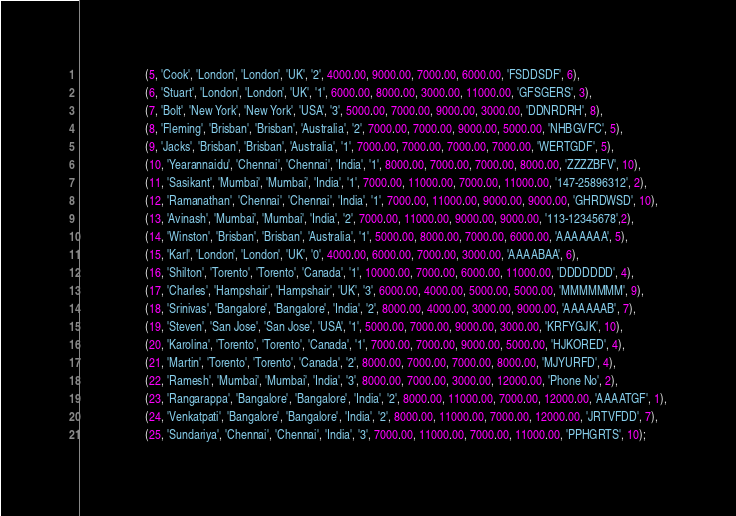<code> <loc_0><loc_0><loc_500><loc_500><_SQL_>                      (5, 'Cook', 'London', 'London', 'UK', '2', 4000.00, 9000.00, 7000.00, 6000.00, 'FSDDSDF', 6),
                      (6, 'Stuart', 'London', 'London', 'UK', '1', 6000.00, 8000.00, 3000.00, 11000.00, 'GFSGERS', 3),
                      (7, 'Bolt', 'New York', 'New York', 'USA', '3', 5000.00, 7000.00, 9000.00, 3000.00, 'DDNRDRH', 8),
                      (8, 'Fleming', 'Brisban', 'Brisban', 'Australia', '2', 7000.00, 7000.00, 9000.00, 5000.00, 'NHBGVFC', 5),
                      (9, 'Jacks', 'Brisban', 'Brisban', 'Australia', '1', 7000.00, 7000.00, 7000.00, 7000.00, 'WERTGDF', 5),
                      (10, 'Yearannaidu', 'Chennai', 'Chennai', 'India', '1', 8000.00, 7000.00, 7000.00, 8000.00, 'ZZZZBFV', 10),
                      (11, 'Sasikant', 'Mumbai', 'Mumbai', 'India', '1', 7000.00, 11000.00, 7000.00, 11000.00, '147-25896312', 2),
                      (12, 'Ramanathan', 'Chennai', 'Chennai', 'India', '1', 7000.00, 11000.00, 9000.00, 9000.00, 'GHRDWSD', 10),
                      (13, 'Avinash', 'Mumbai', 'Mumbai', 'India', '2', 7000.00, 11000.00, 9000.00, 9000.00, '113-12345678',2),
                      (14, 'Winston', 'Brisban', 'Brisban', 'Australia', '1', 5000.00, 8000.00, 7000.00, 6000.00, 'AAAAAAA', 5),
                      (15, 'Karl', 'London', 'London', 'UK', '0', 4000.00, 6000.00, 7000.00, 3000.00, 'AAAABAA', 6),
                      (16, 'Shilton', 'Torento', 'Torento', 'Canada', '1', 10000.00, 7000.00, 6000.00, 11000.00, 'DDDDDDD', 4),
                      (17, 'Charles', 'Hampshair', 'Hampshair', 'UK', '3', 6000.00, 4000.00, 5000.00, 5000.00, 'MMMMMMM', 9),
                      (18, 'Srinivas', 'Bangalore', 'Bangalore', 'India', '2', 8000.00, 4000.00, 3000.00, 9000.00, 'AAAAAAB', 7),
                      (19, 'Steven', 'San Jose', 'San Jose', 'USA', '1', 5000.00, 7000.00, 9000.00, 3000.00, 'KRFYGJK', 10),
                      (20, 'Karolina', 'Torento', 'Torento', 'Canada', '1', 7000.00, 7000.00, 9000.00, 5000.00, 'HJKORED', 4),
                      (21, 'Martin', 'Torento', 'Torento', 'Canada', '2', 8000.00, 7000.00, 7000.00, 8000.00, 'MJYURFD', 4),
                      (22, 'Ramesh', 'Mumbai', 'Mumbai', 'India', '3', 8000.00, 7000.00, 3000.00, 12000.00, 'Phone No', 2),
                      (23, 'Rangarappa', 'Bangalore', 'Bangalore', 'India', '2', 8000.00, 11000.00, 7000.00, 12000.00, 'AAAATGF', 1),
                      (24, 'Venkatpati', 'Bangalore', 'Bangalore', 'India', '2', 8000.00, 11000.00, 7000.00, 12000.00, 'JRTVFDD', 7),
                      (25, 'Sundariya', 'Chennai', 'Chennai', 'India', '3', 7000.00, 11000.00, 7000.00, 11000.00, 'PPHGRTS', 10);
</code> 